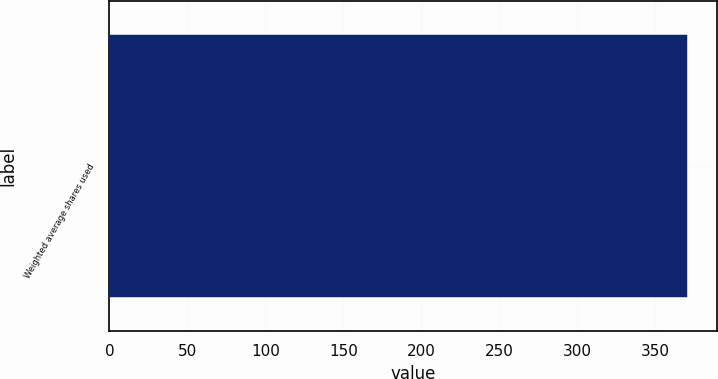Convert chart to OTSL. <chart><loc_0><loc_0><loc_500><loc_500><bar_chart><fcel>Weighted average shares used<nl><fcel>371<nl></chart> 